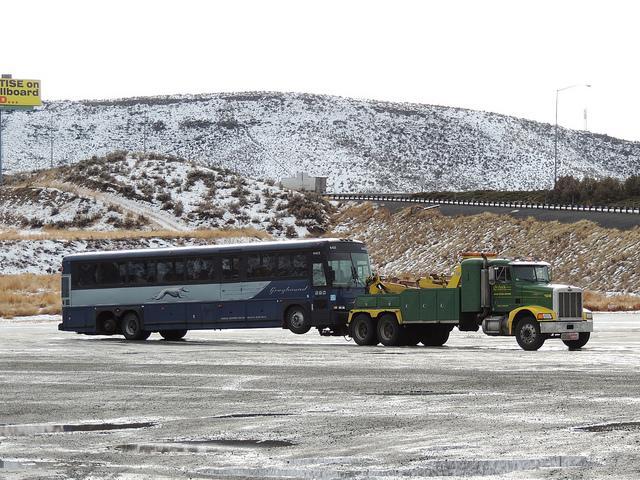Is the area snowy?
Give a very brief answer. Yes. What important item is this bus moving?
Quick response, please. Truck. Is the bus occupied?
Give a very brief answer. No. 